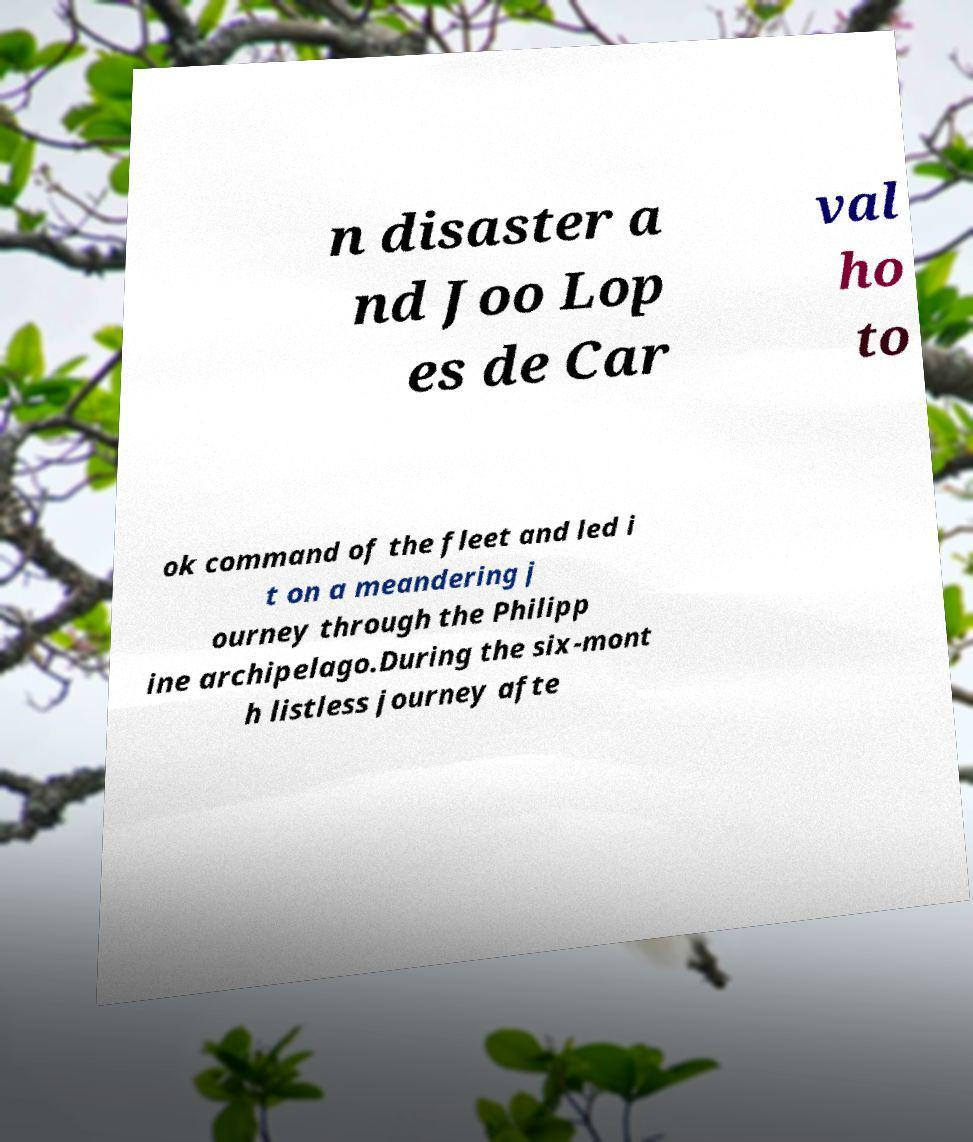Can you read and provide the text displayed in the image?This photo seems to have some interesting text. Can you extract and type it out for me? n disaster a nd Joo Lop es de Car val ho to ok command of the fleet and led i t on a meandering j ourney through the Philipp ine archipelago.During the six-mont h listless journey afte 